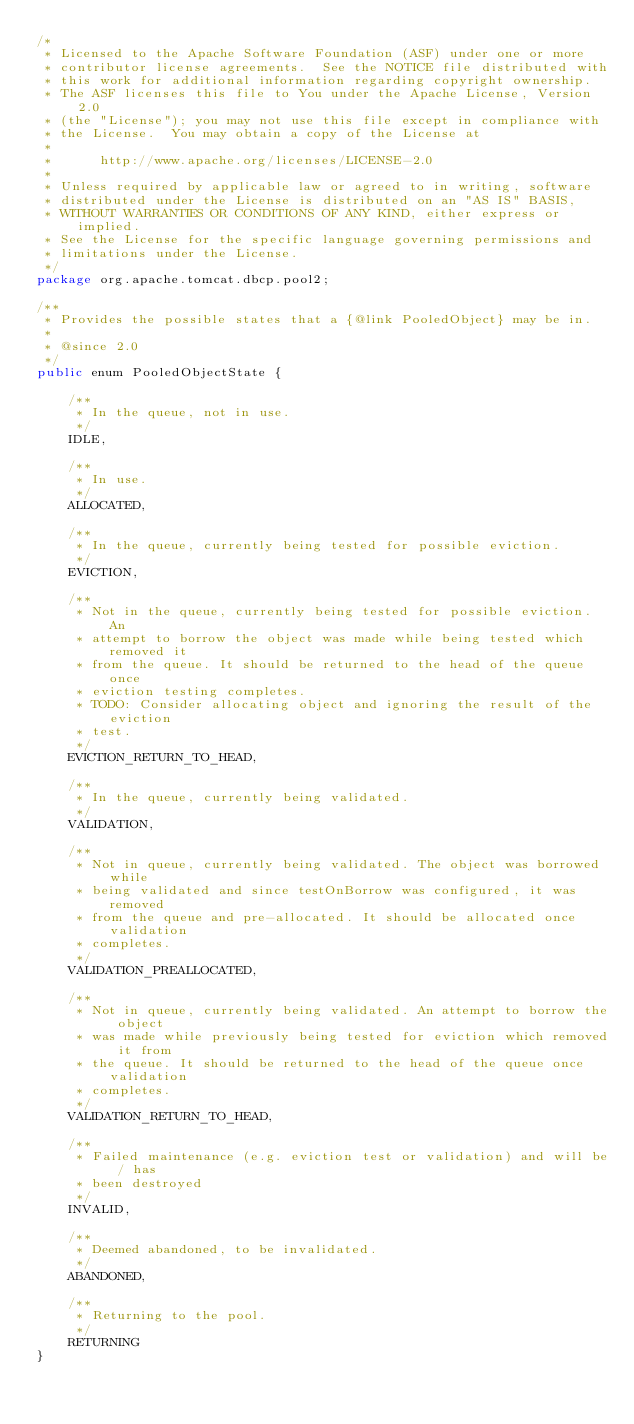<code> <loc_0><loc_0><loc_500><loc_500><_Java_>/*
 * Licensed to the Apache Software Foundation (ASF) under one or more
 * contributor license agreements.  See the NOTICE file distributed with
 * this work for additional information regarding copyright ownership.
 * The ASF licenses this file to You under the Apache License, Version 2.0
 * (the "License"); you may not use this file except in compliance with
 * the License.  You may obtain a copy of the License at
 *
 *      http://www.apache.org/licenses/LICENSE-2.0
 *
 * Unless required by applicable law or agreed to in writing, software
 * distributed under the License is distributed on an "AS IS" BASIS,
 * WITHOUT WARRANTIES OR CONDITIONS OF ANY KIND, either express or implied.
 * See the License for the specific language governing permissions and
 * limitations under the License.
 */
package org.apache.tomcat.dbcp.pool2;

/**
 * Provides the possible states that a {@link PooledObject} may be in.
 *
 * @since 2.0
 */
public enum PooledObjectState {

    /**
     * In the queue, not in use.
     */
    IDLE,

    /**
     * In use.
     */
    ALLOCATED,

    /**
     * In the queue, currently being tested for possible eviction.
     */
    EVICTION,

    /**
     * Not in the queue, currently being tested for possible eviction. An
     * attempt to borrow the object was made while being tested which removed it
     * from the queue. It should be returned to the head of the queue once
     * eviction testing completes.
     * TODO: Consider allocating object and ignoring the result of the eviction
     * test.
     */
    EVICTION_RETURN_TO_HEAD,

    /**
     * In the queue, currently being validated.
     */
    VALIDATION,

    /**
     * Not in queue, currently being validated. The object was borrowed while
     * being validated and since testOnBorrow was configured, it was removed
     * from the queue and pre-allocated. It should be allocated once validation
     * completes.
     */
    VALIDATION_PREALLOCATED,

    /**
     * Not in queue, currently being validated. An attempt to borrow the object
     * was made while previously being tested for eviction which removed it from
     * the queue. It should be returned to the head of the queue once validation
     * completes.
     */
    VALIDATION_RETURN_TO_HEAD,

    /**
     * Failed maintenance (e.g. eviction test or validation) and will be / has
     * been destroyed
     */
    INVALID,

    /**
     * Deemed abandoned, to be invalidated.
     */
    ABANDONED,

    /**
     * Returning to the pool.
     */
    RETURNING
}
</code> 